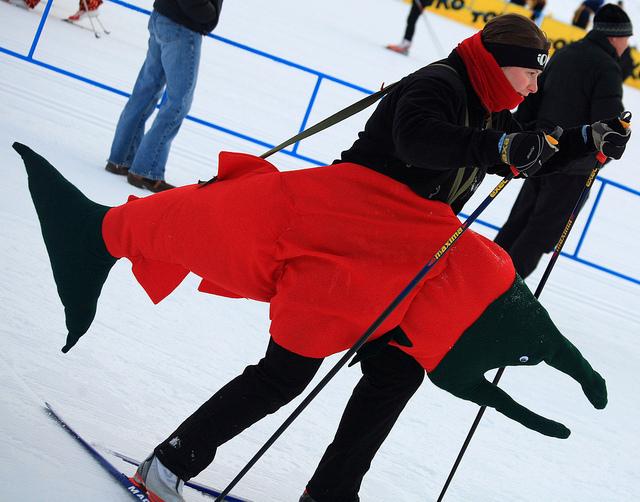Is the woman holding a fish?
Short answer required. Yes. How many people are there?
Short answer required. 3. What are the people doing?
Write a very short answer. Skiing. 